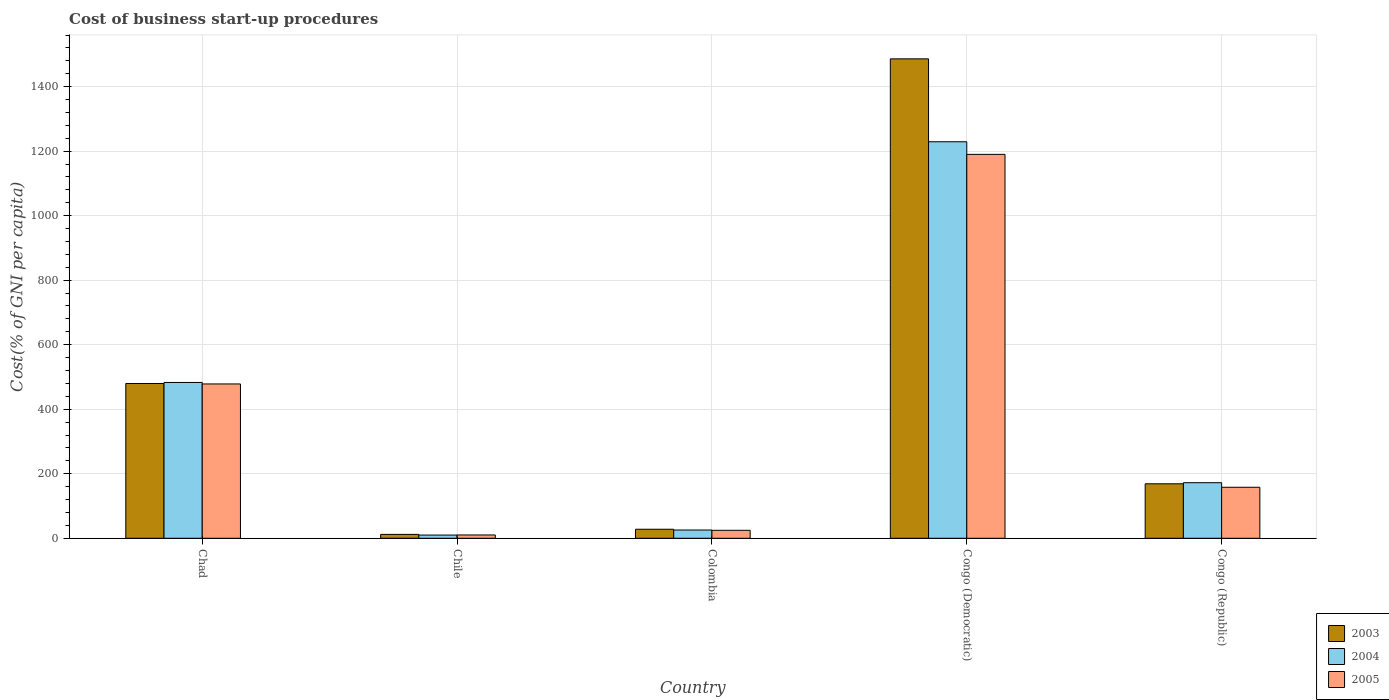How many different coloured bars are there?
Offer a terse response. 3. Are the number of bars per tick equal to the number of legend labels?
Offer a very short reply. Yes. How many bars are there on the 5th tick from the left?
Give a very brief answer. 3. What is the label of the 4th group of bars from the left?
Make the answer very short. Congo (Democratic). What is the cost of business start-up procedures in 2004 in Chad?
Keep it short and to the point. 483. Across all countries, what is the maximum cost of business start-up procedures in 2005?
Make the answer very short. 1190. Across all countries, what is the minimum cost of business start-up procedures in 2005?
Your answer should be very brief. 10.3. In which country was the cost of business start-up procedures in 2004 maximum?
Offer a terse response. Congo (Democratic). In which country was the cost of business start-up procedures in 2004 minimum?
Provide a succinct answer. Chile. What is the total cost of business start-up procedures in 2003 in the graph?
Ensure brevity in your answer.  2174.9. What is the difference between the cost of business start-up procedures in 2005 in Chad and that in Congo (Democratic)?
Ensure brevity in your answer.  -711.6. What is the difference between the cost of business start-up procedures in 2003 in Chile and the cost of business start-up procedures in 2004 in Chad?
Your answer should be very brief. -470.9. What is the average cost of business start-up procedures in 2003 per country?
Your answer should be compact. 434.98. What is the difference between the cost of business start-up procedures of/in 2004 and cost of business start-up procedures of/in 2003 in Colombia?
Your response must be concise. -2.4. In how many countries, is the cost of business start-up procedures in 2003 greater than 680 %?
Offer a very short reply. 1. What is the ratio of the cost of business start-up procedures in 2004 in Chad to that in Chile?
Make the answer very short. 48.3. What is the difference between the highest and the second highest cost of business start-up procedures in 2004?
Keep it short and to the point. 310.7. What is the difference between the highest and the lowest cost of business start-up procedures in 2004?
Provide a short and direct response. 1219.1. What does the 3rd bar from the right in Congo (Republic) represents?
Ensure brevity in your answer.  2003. How many bars are there?
Keep it short and to the point. 15. Are all the bars in the graph horizontal?
Your answer should be compact. No. What is the difference between two consecutive major ticks on the Y-axis?
Your answer should be compact. 200. Does the graph contain grids?
Give a very brief answer. Yes. How many legend labels are there?
Offer a terse response. 3. How are the legend labels stacked?
Your response must be concise. Vertical. What is the title of the graph?
Give a very brief answer. Cost of business start-up procedures. Does "1980" appear as one of the legend labels in the graph?
Give a very brief answer. No. What is the label or title of the X-axis?
Keep it short and to the point. Country. What is the label or title of the Y-axis?
Keep it short and to the point. Cost(% of GNI per capita). What is the Cost(% of GNI per capita) in 2003 in Chad?
Give a very brief answer. 479.8. What is the Cost(% of GNI per capita) in 2004 in Chad?
Offer a very short reply. 483. What is the Cost(% of GNI per capita) in 2005 in Chad?
Provide a short and direct response. 478.4. What is the Cost(% of GNI per capita) in 2003 in Colombia?
Ensure brevity in your answer.  28. What is the Cost(% of GNI per capita) of 2004 in Colombia?
Your answer should be very brief. 25.6. What is the Cost(% of GNI per capita) in 2005 in Colombia?
Offer a terse response. 24.7. What is the Cost(% of GNI per capita) of 2003 in Congo (Democratic)?
Keep it short and to the point. 1486.1. What is the Cost(% of GNI per capita) of 2004 in Congo (Democratic)?
Your answer should be very brief. 1229.1. What is the Cost(% of GNI per capita) in 2005 in Congo (Democratic)?
Ensure brevity in your answer.  1190. What is the Cost(% of GNI per capita) of 2003 in Congo (Republic)?
Your answer should be very brief. 168.9. What is the Cost(% of GNI per capita) of 2004 in Congo (Republic)?
Keep it short and to the point. 172.3. What is the Cost(% of GNI per capita) in 2005 in Congo (Republic)?
Your answer should be compact. 158.1. Across all countries, what is the maximum Cost(% of GNI per capita) in 2003?
Provide a succinct answer. 1486.1. Across all countries, what is the maximum Cost(% of GNI per capita) of 2004?
Make the answer very short. 1229.1. Across all countries, what is the maximum Cost(% of GNI per capita) of 2005?
Give a very brief answer. 1190. What is the total Cost(% of GNI per capita) of 2003 in the graph?
Your answer should be very brief. 2174.9. What is the total Cost(% of GNI per capita) in 2004 in the graph?
Offer a terse response. 1920. What is the total Cost(% of GNI per capita) in 2005 in the graph?
Make the answer very short. 1861.5. What is the difference between the Cost(% of GNI per capita) in 2003 in Chad and that in Chile?
Keep it short and to the point. 467.7. What is the difference between the Cost(% of GNI per capita) of 2004 in Chad and that in Chile?
Ensure brevity in your answer.  473. What is the difference between the Cost(% of GNI per capita) in 2005 in Chad and that in Chile?
Provide a succinct answer. 468.1. What is the difference between the Cost(% of GNI per capita) of 2003 in Chad and that in Colombia?
Provide a short and direct response. 451.8. What is the difference between the Cost(% of GNI per capita) in 2004 in Chad and that in Colombia?
Your answer should be compact. 457.4. What is the difference between the Cost(% of GNI per capita) in 2005 in Chad and that in Colombia?
Offer a very short reply. 453.7. What is the difference between the Cost(% of GNI per capita) in 2003 in Chad and that in Congo (Democratic)?
Ensure brevity in your answer.  -1006.3. What is the difference between the Cost(% of GNI per capita) of 2004 in Chad and that in Congo (Democratic)?
Make the answer very short. -746.1. What is the difference between the Cost(% of GNI per capita) in 2005 in Chad and that in Congo (Democratic)?
Offer a very short reply. -711.6. What is the difference between the Cost(% of GNI per capita) of 2003 in Chad and that in Congo (Republic)?
Your response must be concise. 310.9. What is the difference between the Cost(% of GNI per capita) in 2004 in Chad and that in Congo (Republic)?
Your answer should be compact. 310.7. What is the difference between the Cost(% of GNI per capita) in 2005 in Chad and that in Congo (Republic)?
Make the answer very short. 320.3. What is the difference between the Cost(% of GNI per capita) in 2003 in Chile and that in Colombia?
Your answer should be compact. -15.9. What is the difference between the Cost(% of GNI per capita) in 2004 in Chile and that in Colombia?
Offer a very short reply. -15.6. What is the difference between the Cost(% of GNI per capita) of 2005 in Chile and that in Colombia?
Your answer should be very brief. -14.4. What is the difference between the Cost(% of GNI per capita) in 2003 in Chile and that in Congo (Democratic)?
Your response must be concise. -1474. What is the difference between the Cost(% of GNI per capita) of 2004 in Chile and that in Congo (Democratic)?
Your response must be concise. -1219.1. What is the difference between the Cost(% of GNI per capita) in 2005 in Chile and that in Congo (Democratic)?
Make the answer very short. -1179.7. What is the difference between the Cost(% of GNI per capita) of 2003 in Chile and that in Congo (Republic)?
Provide a short and direct response. -156.8. What is the difference between the Cost(% of GNI per capita) of 2004 in Chile and that in Congo (Republic)?
Provide a succinct answer. -162.3. What is the difference between the Cost(% of GNI per capita) of 2005 in Chile and that in Congo (Republic)?
Provide a short and direct response. -147.8. What is the difference between the Cost(% of GNI per capita) in 2003 in Colombia and that in Congo (Democratic)?
Ensure brevity in your answer.  -1458.1. What is the difference between the Cost(% of GNI per capita) of 2004 in Colombia and that in Congo (Democratic)?
Keep it short and to the point. -1203.5. What is the difference between the Cost(% of GNI per capita) of 2005 in Colombia and that in Congo (Democratic)?
Ensure brevity in your answer.  -1165.3. What is the difference between the Cost(% of GNI per capita) of 2003 in Colombia and that in Congo (Republic)?
Your answer should be compact. -140.9. What is the difference between the Cost(% of GNI per capita) of 2004 in Colombia and that in Congo (Republic)?
Offer a terse response. -146.7. What is the difference between the Cost(% of GNI per capita) of 2005 in Colombia and that in Congo (Republic)?
Provide a succinct answer. -133.4. What is the difference between the Cost(% of GNI per capita) in 2003 in Congo (Democratic) and that in Congo (Republic)?
Your answer should be very brief. 1317.2. What is the difference between the Cost(% of GNI per capita) in 2004 in Congo (Democratic) and that in Congo (Republic)?
Provide a succinct answer. 1056.8. What is the difference between the Cost(% of GNI per capita) in 2005 in Congo (Democratic) and that in Congo (Republic)?
Your answer should be compact. 1031.9. What is the difference between the Cost(% of GNI per capita) of 2003 in Chad and the Cost(% of GNI per capita) of 2004 in Chile?
Keep it short and to the point. 469.8. What is the difference between the Cost(% of GNI per capita) in 2003 in Chad and the Cost(% of GNI per capita) in 2005 in Chile?
Your answer should be compact. 469.5. What is the difference between the Cost(% of GNI per capita) of 2004 in Chad and the Cost(% of GNI per capita) of 2005 in Chile?
Keep it short and to the point. 472.7. What is the difference between the Cost(% of GNI per capita) in 2003 in Chad and the Cost(% of GNI per capita) in 2004 in Colombia?
Your response must be concise. 454.2. What is the difference between the Cost(% of GNI per capita) in 2003 in Chad and the Cost(% of GNI per capita) in 2005 in Colombia?
Keep it short and to the point. 455.1. What is the difference between the Cost(% of GNI per capita) in 2004 in Chad and the Cost(% of GNI per capita) in 2005 in Colombia?
Keep it short and to the point. 458.3. What is the difference between the Cost(% of GNI per capita) in 2003 in Chad and the Cost(% of GNI per capita) in 2004 in Congo (Democratic)?
Offer a very short reply. -749.3. What is the difference between the Cost(% of GNI per capita) of 2003 in Chad and the Cost(% of GNI per capita) of 2005 in Congo (Democratic)?
Your answer should be very brief. -710.2. What is the difference between the Cost(% of GNI per capita) of 2004 in Chad and the Cost(% of GNI per capita) of 2005 in Congo (Democratic)?
Your answer should be very brief. -707. What is the difference between the Cost(% of GNI per capita) in 2003 in Chad and the Cost(% of GNI per capita) in 2004 in Congo (Republic)?
Provide a succinct answer. 307.5. What is the difference between the Cost(% of GNI per capita) of 2003 in Chad and the Cost(% of GNI per capita) of 2005 in Congo (Republic)?
Your answer should be very brief. 321.7. What is the difference between the Cost(% of GNI per capita) in 2004 in Chad and the Cost(% of GNI per capita) in 2005 in Congo (Republic)?
Make the answer very short. 324.9. What is the difference between the Cost(% of GNI per capita) in 2003 in Chile and the Cost(% of GNI per capita) in 2004 in Colombia?
Your answer should be very brief. -13.5. What is the difference between the Cost(% of GNI per capita) of 2003 in Chile and the Cost(% of GNI per capita) of 2005 in Colombia?
Make the answer very short. -12.6. What is the difference between the Cost(% of GNI per capita) in 2004 in Chile and the Cost(% of GNI per capita) in 2005 in Colombia?
Your answer should be compact. -14.7. What is the difference between the Cost(% of GNI per capita) in 2003 in Chile and the Cost(% of GNI per capita) in 2004 in Congo (Democratic)?
Give a very brief answer. -1217. What is the difference between the Cost(% of GNI per capita) of 2003 in Chile and the Cost(% of GNI per capita) of 2005 in Congo (Democratic)?
Keep it short and to the point. -1177.9. What is the difference between the Cost(% of GNI per capita) in 2004 in Chile and the Cost(% of GNI per capita) in 2005 in Congo (Democratic)?
Keep it short and to the point. -1180. What is the difference between the Cost(% of GNI per capita) of 2003 in Chile and the Cost(% of GNI per capita) of 2004 in Congo (Republic)?
Provide a succinct answer. -160.2. What is the difference between the Cost(% of GNI per capita) of 2003 in Chile and the Cost(% of GNI per capita) of 2005 in Congo (Republic)?
Make the answer very short. -146. What is the difference between the Cost(% of GNI per capita) in 2004 in Chile and the Cost(% of GNI per capita) in 2005 in Congo (Republic)?
Your answer should be compact. -148.1. What is the difference between the Cost(% of GNI per capita) of 2003 in Colombia and the Cost(% of GNI per capita) of 2004 in Congo (Democratic)?
Ensure brevity in your answer.  -1201.1. What is the difference between the Cost(% of GNI per capita) of 2003 in Colombia and the Cost(% of GNI per capita) of 2005 in Congo (Democratic)?
Make the answer very short. -1162. What is the difference between the Cost(% of GNI per capita) of 2004 in Colombia and the Cost(% of GNI per capita) of 2005 in Congo (Democratic)?
Your answer should be very brief. -1164.4. What is the difference between the Cost(% of GNI per capita) in 2003 in Colombia and the Cost(% of GNI per capita) in 2004 in Congo (Republic)?
Offer a very short reply. -144.3. What is the difference between the Cost(% of GNI per capita) in 2003 in Colombia and the Cost(% of GNI per capita) in 2005 in Congo (Republic)?
Your answer should be compact. -130.1. What is the difference between the Cost(% of GNI per capita) in 2004 in Colombia and the Cost(% of GNI per capita) in 2005 in Congo (Republic)?
Your response must be concise. -132.5. What is the difference between the Cost(% of GNI per capita) of 2003 in Congo (Democratic) and the Cost(% of GNI per capita) of 2004 in Congo (Republic)?
Your answer should be very brief. 1313.8. What is the difference between the Cost(% of GNI per capita) in 2003 in Congo (Democratic) and the Cost(% of GNI per capita) in 2005 in Congo (Republic)?
Your answer should be very brief. 1328. What is the difference between the Cost(% of GNI per capita) in 2004 in Congo (Democratic) and the Cost(% of GNI per capita) in 2005 in Congo (Republic)?
Keep it short and to the point. 1071. What is the average Cost(% of GNI per capita) in 2003 per country?
Provide a succinct answer. 434.98. What is the average Cost(% of GNI per capita) in 2004 per country?
Give a very brief answer. 384. What is the average Cost(% of GNI per capita) in 2005 per country?
Give a very brief answer. 372.3. What is the difference between the Cost(% of GNI per capita) of 2003 and Cost(% of GNI per capita) of 2004 in Chad?
Ensure brevity in your answer.  -3.2. What is the difference between the Cost(% of GNI per capita) of 2003 and Cost(% of GNI per capita) of 2005 in Chad?
Make the answer very short. 1.4. What is the difference between the Cost(% of GNI per capita) of 2004 and Cost(% of GNI per capita) of 2005 in Chad?
Your answer should be very brief. 4.6. What is the difference between the Cost(% of GNI per capita) of 2003 and Cost(% of GNI per capita) of 2004 in Chile?
Ensure brevity in your answer.  2.1. What is the difference between the Cost(% of GNI per capita) in 2003 and Cost(% of GNI per capita) in 2005 in Chile?
Your answer should be very brief. 1.8. What is the difference between the Cost(% of GNI per capita) of 2003 and Cost(% of GNI per capita) of 2005 in Colombia?
Ensure brevity in your answer.  3.3. What is the difference between the Cost(% of GNI per capita) in 2004 and Cost(% of GNI per capita) in 2005 in Colombia?
Offer a terse response. 0.9. What is the difference between the Cost(% of GNI per capita) of 2003 and Cost(% of GNI per capita) of 2004 in Congo (Democratic)?
Your answer should be compact. 257. What is the difference between the Cost(% of GNI per capita) in 2003 and Cost(% of GNI per capita) in 2005 in Congo (Democratic)?
Offer a terse response. 296.1. What is the difference between the Cost(% of GNI per capita) of 2004 and Cost(% of GNI per capita) of 2005 in Congo (Democratic)?
Your answer should be compact. 39.1. What is the difference between the Cost(% of GNI per capita) of 2003 and Cost(% of GNI per capita) of 2004 in Congo (Republic)?
Provide a short and direct response. -3.4. What is the ratio of the Cost(% of GNI per capita) of 2003 in Chad to that in Chile?
Provide a short and direct response. 39.65. What is the ratio of the Cost(% of GNI per capita) in 2004 in Chad to that in Chile?
Keep it short and to the point. 48.3. What is the ratio of the Cost(% of GNI per capita) of 2005 in Chad to that in Chile?
Your answer should be very brief. 46.45. What is the ratio of the Cost(% of GNI per capita) of 2003 in Chad to that in Colombia?
Your answer should be compact. 17.14. What is the ratio of the Cost(% of GNI per capita) in 2004 in Chad to that in Colombia?
Make the answer very short. 18.87. What is the ratio of the Cost(% of GNI per capita) in 2005 in Chad to that in Colombia?
Offer a very short reply. 19.37. What is the ratio of the Cost(% of GNI per capita) of 2003 in Chad to that in Congo (Democratic)?
Keep it short and to the point. 0.32. What is the ratio of the Cost(% of GNI per capita) of 2004 in Chad to that in Congo (Democratic)?
Your response must be concise. 0.39. What is the ratio of the Cost(% of GNI per capita) in 2005 in Chad to that in Congo (Democratic)?
Your answer should be very brief. 0.4. What is the ratio of the Cost(% of GNI per capita) in 2003 in Chad to that in Congo (Republic)?
Keep it short and to the point. 2.84. What is the ratio of the Cost(% of GNI per capita) of 2004 in Chad to that in Congo (Republic)?
Your response must be concise. 2.8. What is the ratio of the Cost(% of GNI per capita) in 2005 in Chad to that in Congo (Republic)?
Provide a short and direct response. 3.03. What is the ratio of the Cost(% of GNI per capita) in 2003 in Chile to that in Colombia?
Offer a terse response. 0.43. What is the ratio of the Cost(% of GNI per capita) in 2004 in Chile to that in Colombia?
Make the answer very short. 0.39. What is the ratio of the Cost(% of GNI per capita) of 2005 in Chile to that in Colombia?
Keep it short and to the point. 0.42. What is the ratio of the Cost(% of GNI per capita) of 2003 in Chile to that in Congo (Democratic)?
Keep it short and to the point. 0.01. What is the ratio of the Cost(% of GNI per capita) in 2004 in Chile to that in Congo (Democratic)?
Offer a terse response. 0.01. What is the ratio of the Cost(% of GNI per capita) in 2005 in Chile to that in Congo (Democratic)?
Make the answer very short. 0.01. What is the ratio of the Cost(% of GNI per capita) of 2003 in Chile to that in Congo (Republic)?
Make the answer very short. 0.07. What is the ratio of the Cost(% of GNI per capita) in 2004 in Chile to that in Congo (Republic)?
Provide a succinct answer. 0.06. What is the ratio of the Cost(% of GNI per capita) of 2005 in Chile to that in Congo (Republic)?
Provide a succinct answer. 0.07. What is the ratio of the Cost(% of GNI per capita) of 2003 in Colombia to that in Congo (Democratic)?
Offer a very short reply. 0.02. What is the ratio of the Cost(% of GNI per capita) in 2004 in Colombia to that in Congo (Democratic)?
Make the answer very short. 0.02. What is the ratio of the Cost(% of GNI per capita) of 2005 in Colombia to that in Congo (Democratic)?
Your answer should be very brief. 0.02. What is the ratio of the Cost(% of GNI per capita) of 2003 in Colombia to that in Congo (Republic)?
Your response must be concise. 0.17. What is the ratio of the Cost(% of GNI per capita) in 2004 in Colombia to that in Congo (Republic)?
Ensure brevity in your answer.  0.15. What is the ratio of the Cost(% of GNI per capita) in 2005 in Colombia to that in Congo (Republic)?
Offer a terse response. 0.16. What is the ratio of the Cost(% of GNI per capita) in 2003 in Congo (Democratic) to that in Congo (Republic)?
Give a very brief answer. 8.8. What is the ratio of the Cost(% of GNI per capita) of 2004 in Congo (Democratic) to that in Congo (Republic)?
Give a very brief answer. 7.13. What is the ratio of the Cost(% of GNI per capita) of 2005 in Congo (Democratic) to that in Congo (Republic)?
Give a very brief answer. 7.53. What is the difference between the highest and the second highest Cost(% of GNI per capita) of 2003?
Your answer should be very brief. 1006.3. What is the difference between the highest and the second highest Cost(% of GNI per capita) of 2004?
Make the answer very short. 746.1. What is the difference between the highest and the second highest Cost(% of GNI per capita) of 2005?
Make the answer very short. 711.6. What is the difference between the highest and the lowest Cost(% of GNI per capita) of 2003?
Provide a short and direct response. 1474. What is the difference between the highest and the lowest Cost(% of GNI per capita) of 2004?
Provide a short and direct response. 1219.1. What is the difference between the highest and the lowest Cost(% of GNI per capita) in 2005?
Keep it short and to the point. 1179.7. 